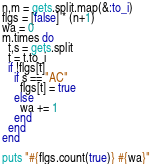Convert code to text. <code><loc_0><loc_0><loc_500><loc_500><_Ruby_>n,m = gets.split.map(&:to_i)
flgs = [false] * (n+1)
wa = 0
m.times do 
  t,s = gets.split
  t = t.to_i
  if !flgs[t]
    if s == "AC"
      flgs[t] = true
    else
      wa += 1
    end
  end
end

puts "#{flgs.count(true)} #{wa}"</code> 